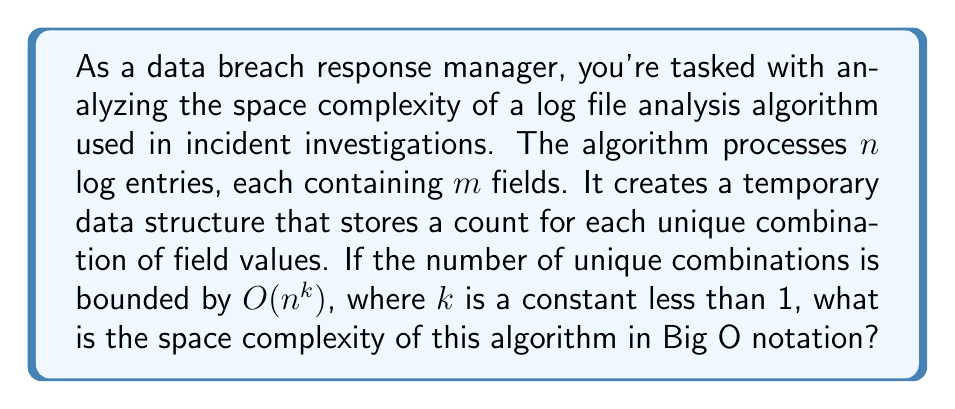Show me your answer to this math problem. To determine the space complexity of this algorithm, let's break down the problem and analyze it step by step:

1. Input size:
   - There are $n$ log entries
   - Each entry has $m$ fields

2. Temporary data structure:
   - Stores counts for unique combinations of field values
   - The number of unique combinations is bounded by $O(n^k)$, where $k < 1$

3. Space required for each combination:
   - We need to store the field values and the count
   - Field values: $O(m)$ space (assuming constant space for each field value)
   - Count: $O(1)$ space
   - Total space per combination: $O(m + 1) = O(m)$

4. Total space complexity:
   - Number of combinations: $O(n^k)$
   - Space per combination: $O(m)$
   - Total space: $O(n^k) \cdot O(m) = O(n^k m)$

5. Simplification:
   - Since $k < 1$, $n^k$ grows slower than $n$
   - The space complexity is dominated by $n^k m$

Therefore, the space complexity of the algorithm is $O(n^k m)$, where $k < 1$.

This analysis is crucial for a data breach response manager to understand the resource requirements of log analysis tools used in incident investigations, especially when dealing with large-scale breaches involving massive log files.
Answer: $O(n^k m)$, where $k < 1$ 